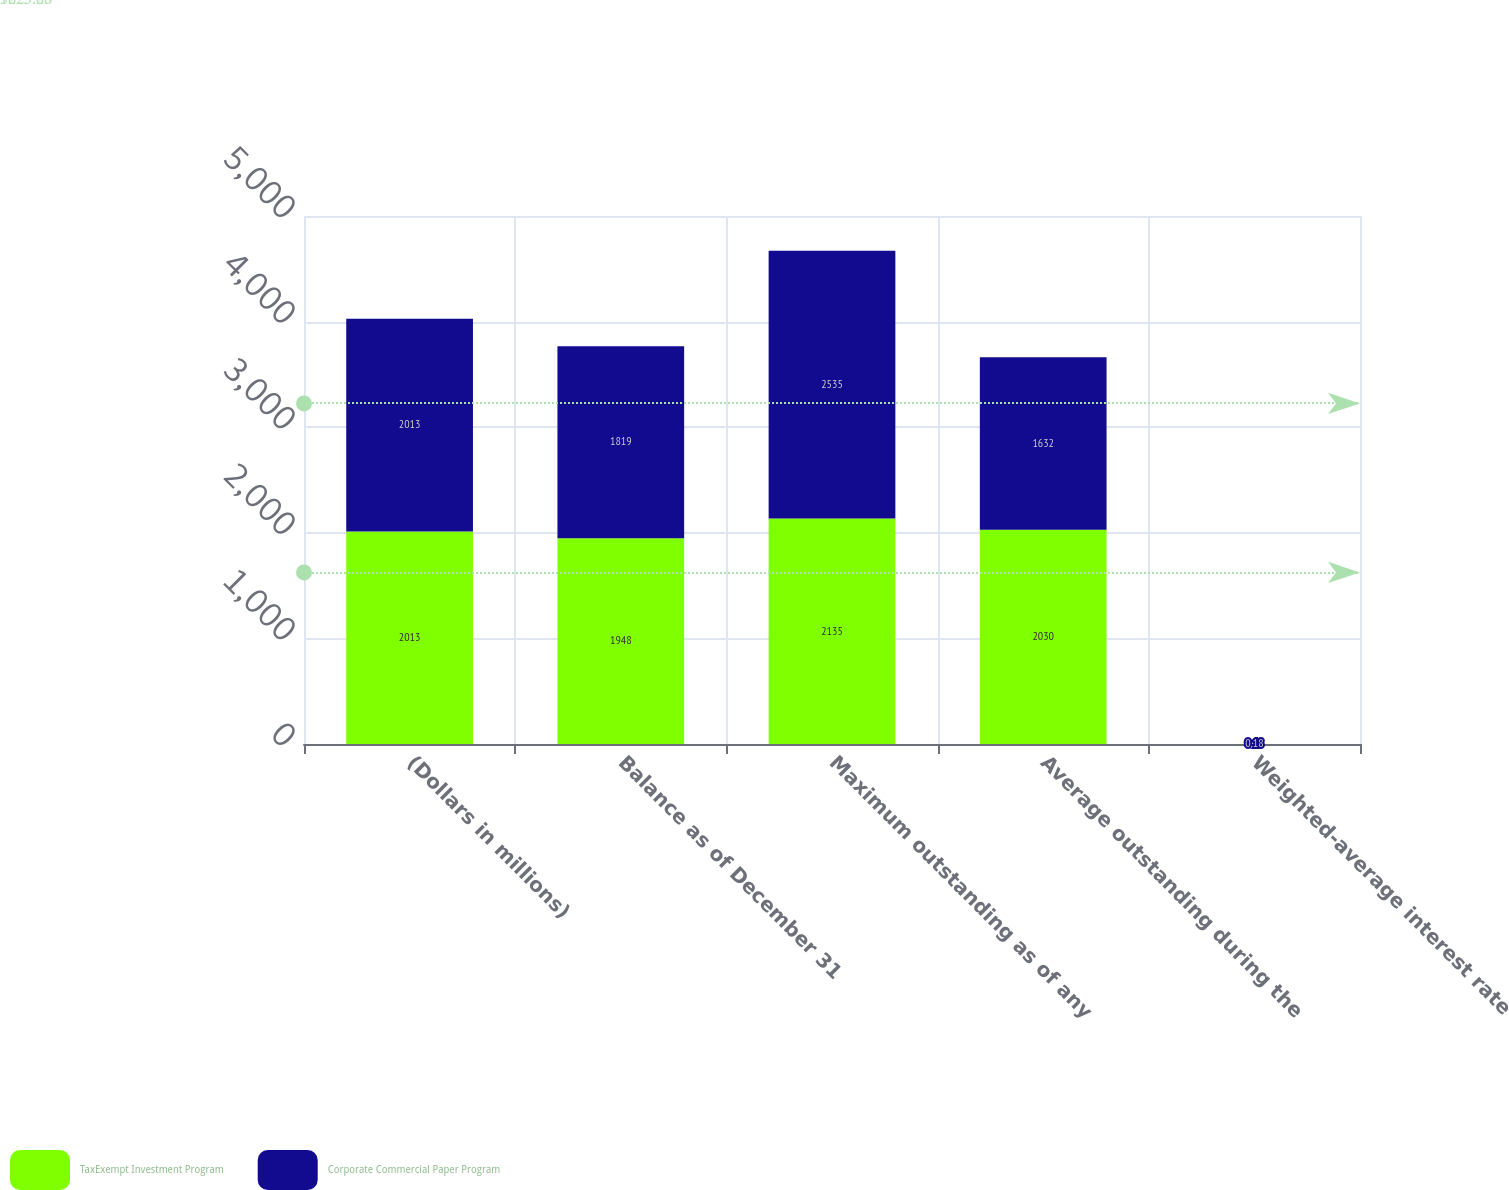Convert chart to OTSL. <chart><loc_0><loc_0><loc_500><loc_500><stacked_bar_chart><ecel><fcel>(Dollars in millions)<fcel>Balance as of December 31<fcel>Maximum outstanding as of any<fcel>Average outstanding during the<fcel>Weighted-average interest rate<nl><fcel>TaxExempt Investment Program<fcel>2013<fcel>1948<fcel>2135<fcel>2030<fcel>0.13<nl><fcel>Corporate Commercial Paper Program<fcel>2013<fcel>1819<fcel>2535<fcel>1632<fcel>0.18<nl></chart> 